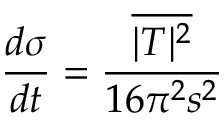<formula> <loc_0><loc_0><loc_500><loc_500>{ \frac { d \sigma } { d t } } = { \frac { \overline { { | T | ^ { 2 } } } } { 1 6 \pi ^ { 2 } s ^ { 2 } } }</formula> 